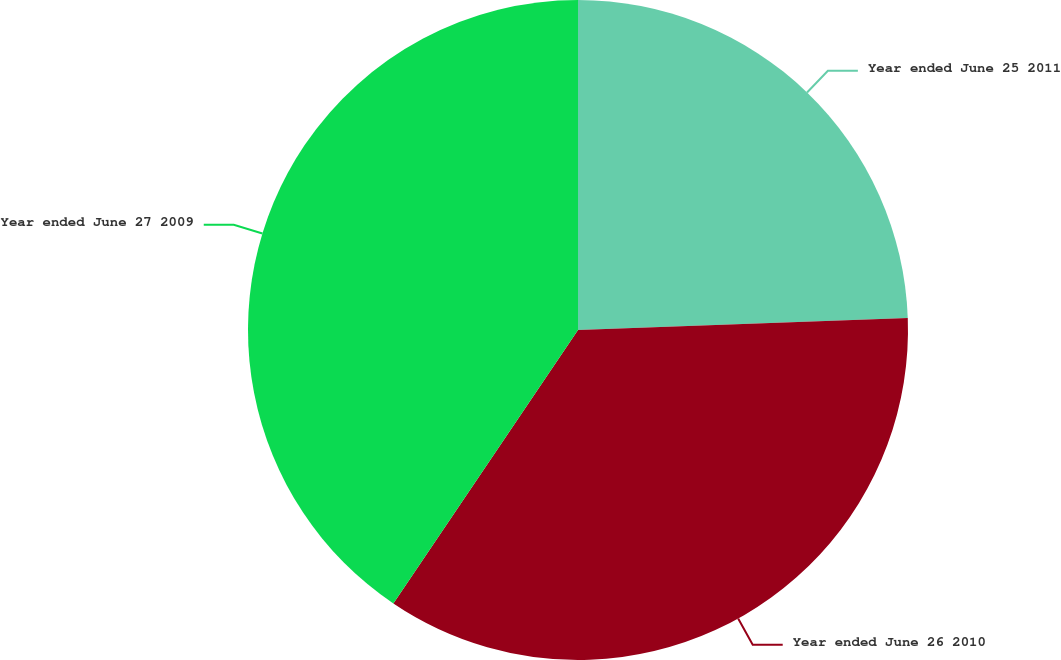Convert chart to OTSL. <chart><loc_0><loc_0><loc_500><loc_500><pie_chart><fcel>Year ended June 25 2011<fcel>Year ended June 26 2010<fcel>Year ended June 27 2009<nl><fcel>24.42%<fcel>35.03%<fcel>40.55%<nl></chart> 